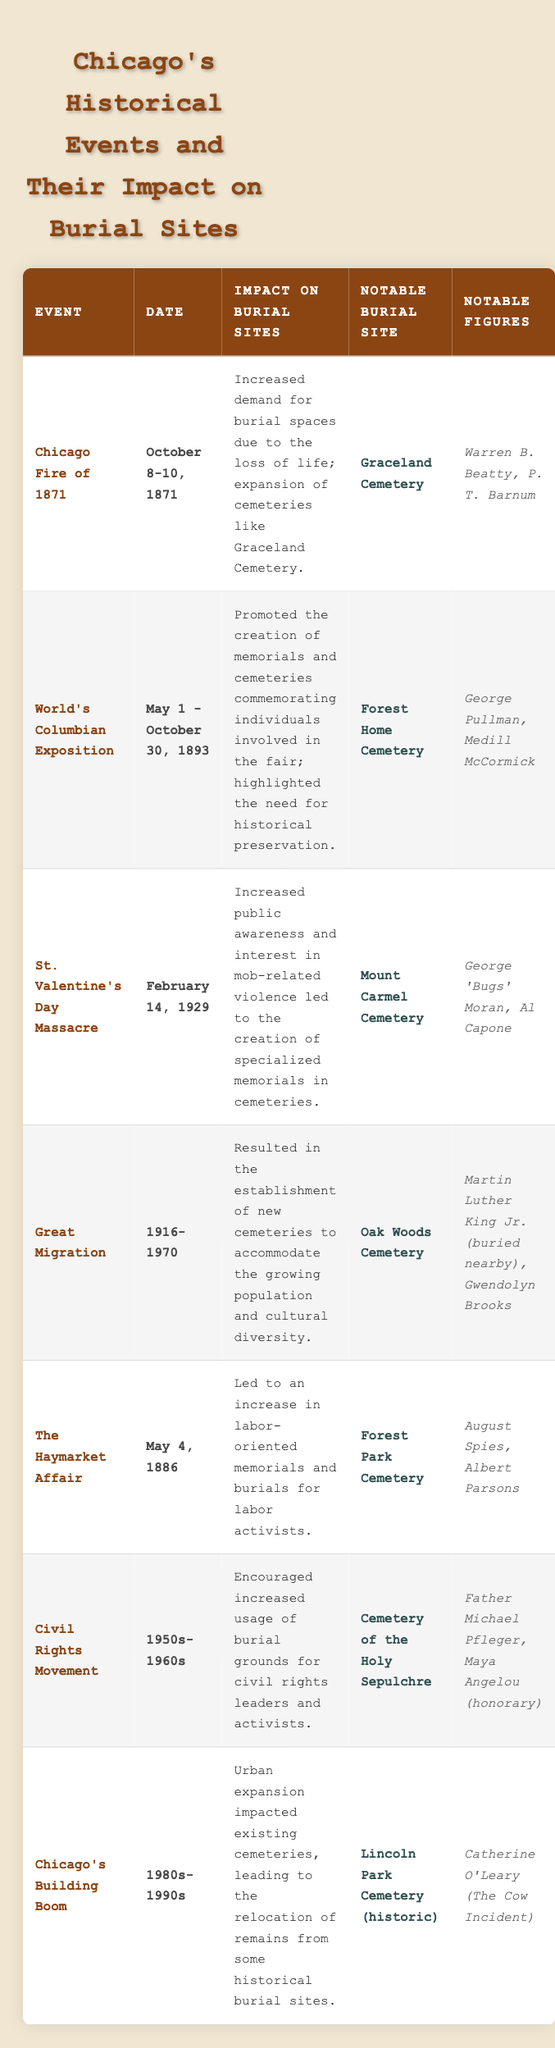What event led to an increased demand for burial spaces in Chicago? The table indicates that the "Chicago Fire of 1871" resulted in an increased demand for burial spaces due to the loss of life. This event is explicitly mentioned in the corresponding row under "Impact on Burial Sites."
Answer: Chicago Fire of 1871 Which notable figures are associated with Graceland Cemetery? According to the table, the notable figures associated with Graceland Cemetery are Warren B. Beatty and P. T. Barnum. This information is directly retrieved from the "Notable Figures" column in the row for the Chicago Fire of 1871.
Answer: Warren B. Beatty, P. T. Barnum What impact did the Great Migration have on burial sites? The table states that the Great Migration resulted in the establishment of new cemeteries to accommodate the growing population and cultural diversity. This is found in the "Impact on Burial Sites" section under the respective event row.
Answer: Establishment of new cemeteries True or False: The St. Valentine's Day Massacre led to the creation of specialized memorials in cemeteries. The table confirms that the St. Valentine's Day Massacre increased public awareness and interest in mob-related violence, which did lead to the creation of specialized memorials. Therefore, the statement is true based on the information presented.
Answer: True Which event occurred between 1950 and 1960, and what was its impact on burial sites? The table indicates the "Civil Rights Movement" as an event occurring during the 1950s to 1960s. It led to increased usage of burial grounds for civil rights leaders and activists, as stated in the "Impact on Burial Sites" section.
Answer: Civil Rights Movement; increased usage of burial grounds What are the notable burial sites mentioned for the World's Columbian Exposition? The notable burial site for the World's Columbian Exposition, as found in the table, is Forest Home Cemetery. This is directly listed under the "Notable Burial Site" column for the associated event row.
Answer: Forest Home Cemetery How many events mentioned in the table relate to labor movements? Two events are related to labor movements: "The Haymarket Affair" (which increased labor-oriented memorials) and indirectly tied to the “Civil Rights Movement” through labor advancements. Therefore, we conclude there are two events with direct or indirect connections.
Answer: Two events What is the impact of Chicago's Building Boom on historical burial sites? The table indicates that the Chicago's Building Boom led to urban expansion which impacted existing cemeteries, resulting in the relocation of remains from some historical burial sites. This explains the effect on burial sites during that period.
Answer: Relocation of remains from historical burial sites Which notable figure is buried near Oak Woods Cemetery? The table states that Martin Luther King Jr. is buried nearby Oak Woods Cemetery, which can be directly identified in the notable figures section associated with the event of the Great Migration.
Answer: Martin Luther King Jr. (buried nearby) 